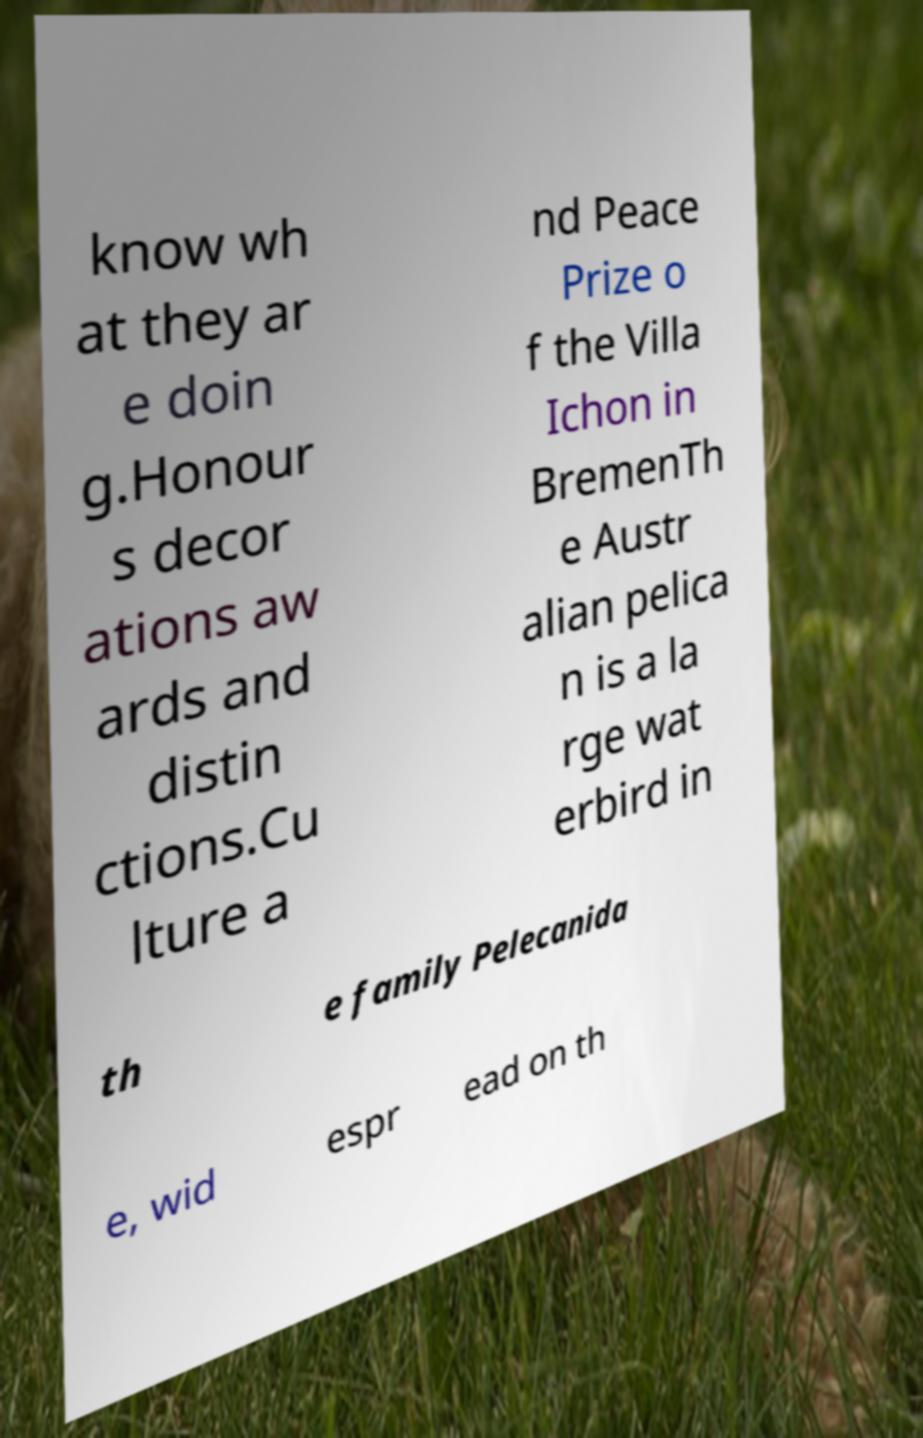I need the written content from this picture converted into text. Can you do that? know wh at they ar e doin g.Honour s decor ations aw ards and distin ctions.Cu lture a nd Peace Prize o f the Villa Ichon in BremenTh e Austr alian pelica n is a la rge wat erbird in th e family Pelecanida e, wid espr ead on th 